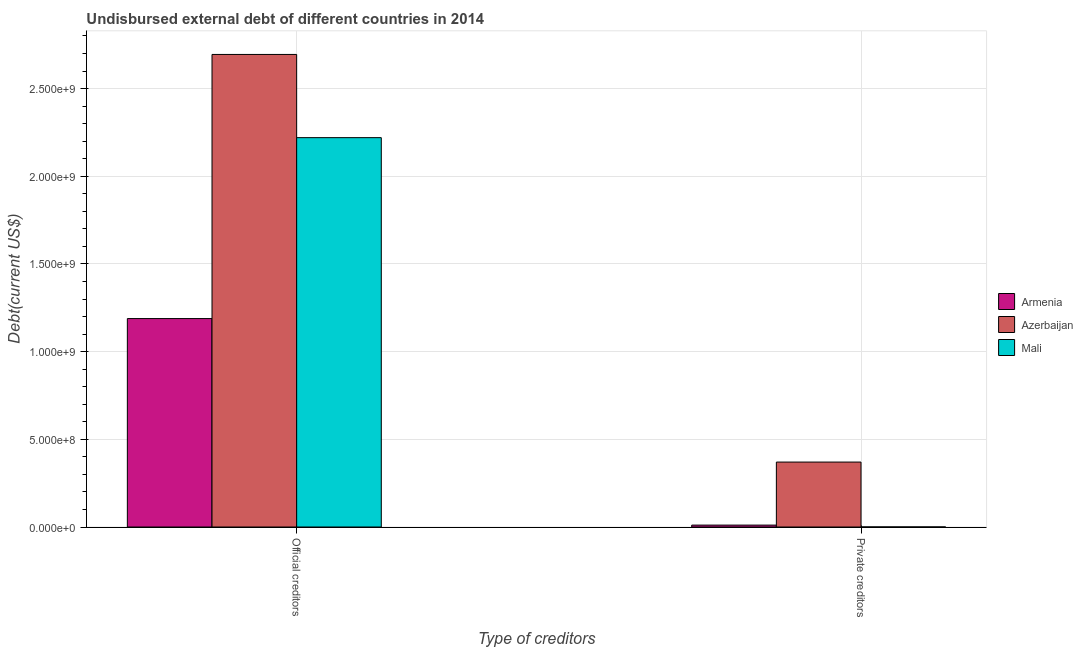Are the number of bars per tick equal to the number of legend labels?
Give a very brief answer. Yes. Are the number of bars on each tick of the X-axis equal?
Your answer should be compact. Yes. How many bars are there on the 2nd tick from the left?
Ensure brevity in your answer.  3. How many bars are there on the 2nd tick from the right?
Your answer should be very brief. 3. What is the label of the 2nd group of bars from the left?
Offer a terse response. Private creditors. What is the undisbursed external debt of private creditors in Armenia?
Give a very brief answer. 1.09e+07. Across all countries, what is the maximum undisbursed external debt of official creditors?
Make the answer very short. 2.69e+09. Across all countries, what is the minimum undisbursed external debt of official creditors?
Your response must be concise. 1.19e+09. In which country was the undisbursed external debt of official creditors maximum?
Make the answer very short. Azerbaijan. In which country was the undisbursed external debt of official creditors minimum?
Provide a short and direct response. Armenia. What is the total undisbursed external debt of private creditors in the graph?
Offer a very short reply. 3.82e+08. What is the difference between the undisbursed external debt of private creditors in Armenia and that in Mali?
Offer a very short reply. 1.05e+07. What is the difference between the undisbursed external debt of official creditors in Mali and the undisbursed external debt of private creditors in Armenia?
Keep it short and to the point. 2.21e+09. What is the average undisbursed external debt of official creditors per country?
Offer a very short reply. 2.03e+09. What is the difference between the undisbursed external debt of official creditors and undisbursed external debt of private creditors in Azerbaijan?
Your answer should be very brief. 2.32e+09. What is the ratio of the undisbursed external debt of official creditors in Mali to that in Armenia?
Your answer should be compact. 1.87. In how many countries, is the undisbursed external debt of private creditors greater than the average undisbursed external debt of private creditors taken over all countries?
Offer a terse response. 1. What does the 1st bar from the left in Private creditors represents?
Offer a terse response. Armenia. What does the 1st bar from the right in Official creditors represents?
Ensure brevity in your answer.  Mali. How many bars are there?
Your answer should be very brief. 6. Are all the bars in the graph horizontal?
Offer a terse response. No. Are the values on the major ticks of Y-axis written in scientific E-notation?
Provide a succinct answer. Yes. What is the title of the graph?
Your response must be concise. Undisbursed external debt of different countries in 2014. Does "United States" appear as one of the legend labels in the graph?
Keep it short and to the point. No. What is the label or title of the X-axis?
Keep it short and to the point. Type of creditors. What is the label or title of the Y-axis?
Provide a short and direct response. Debt(current US$). What is the Debt(current US$) of Armenia in Official creditors?
Provide a succinct answer. 1.19e+09. What is the Debt(current US$) in Azerbaijan in Official creditors?
Offer a terse response. 2.69e+09. What is the Debt(current US$) of Mali in Official creditors?
Your answer should be compact. 2.22e+09. What is the Debt(current US$) of Armenia in Private creditors?
Your answer should be compact. 1.09e+07. What is the Debt(current US$) of Azerbaijan in Private creditors?
Keep it short and to the point. 3.70e+08. What is the Debt(current US$) of Mali in Private creditors?
Provide a succinct answer. 3.87e+05. Across all Type of creditors, what is the maximum Debt(current US$) of Armenia?
Make the answer very short. 1.19e+09. Across all Type of creditors, what is the maximum Debt(current US$) of Azerbaijan?
Keep it short and to the point. 2.69e+09. Across all Type of creditors, what is the maximum Debt(current US$) in Mali?
Make the answer very short. 2.22e+09. Across all Type of creditors, what is the minimum Debt(current US$) in Armenia?
Keep it short and to the point. 1.09e+07. Across all Type of creditors, what is the minimum Debt(current US$) in Azerbaijan?
Your response must be concise. 3.70e+08. Across all Type of creditors, what is the minimum Debt(current US$) in Mali?
Give a very brief answer. 3.87e+05. What is the total Debt(current US$) in Armenia in the graph?
Your answer should be compact. 1.20e+09. What is the total Debt(current US$) of Azerbaijan in the graph?
Make the answer very short. 3.07e+09. What is the total Debt(current US$) of Mali in the graph?
Provide a succinct answer. 2.22e+09. What is the difference between the Debt(current US$) of Armenia in Official creditors and that in Private creditors?
Make the answer very short. 1.18e+09. What is the difference between the Debt(current US$) of Azerbaijan in Official creditors and that in Private creditors?
Make the answer very short. 2.32e+09. What is the difference between the Debt(current US$) of Mali in Official creditors and that in Private creditors?
Your response must be concise. 2.22e+09. What is the difference between the Debt(current US$) of Armenia in Official creditors and the Debt(current US$) of Azerbaijan in Private creditors?
Ensure brevity in your answer.  8.18e+08. What is the difference between the Debt(current US$) in Armenia in Official creditors and the Debt(current US$) in Mali in Private creditors?
Offer a very short reply. 1.19e+09. What is the difference between the Debt(current US$) in Azerbaijan in Official creditors and the Debt(current US$) in Mali in Private creditors?
Your answer should be compact. 2.69e+09. What is the average Debt(current US$) in Armenia per Type of creditors?
Your response must be concise. 6.00e+08. What is the average Debt(current US$) in Azerbaijan per Type of creditors?
Provide a short and direct response. 1.53e+09. What is the average Debt(current US$) in Mali per Type of creditors?
Give a very brief answer. 1.11e+09. What is the difference between the Debt(current US$) in Armenia and Debt(current US$) in Azerbaijan in Official creditors?
Give a very brief answer. -1.51e+09. What is the difference between the Debt(current US$) in Armenia and Debt(current US$) in Mali in Official creditors?
Offer a terse response. -1.03e+09. What is the difference between the Debt(current US$) of Azerbaijan and Debt(current US$) of Mali in Official creditors?
Your answer should be compact. 4.74e+08. What is the difference between the Debt(current US$) of Armenia and Debt(current US$) of Azerbaijan in Private creditors?
Your response must be concise. -3.59e+08. What is the difference between the Debt(current US$) in Armenia and Debt(current US$) in Mali in Private creditors?
Keep it short and to the point. 1.05e+07. What is the difference between the Debt(current US$) of Azerbaijan and Debt(current US$) of Mali in Private creditors?
Your answer should be very brief. 3.70e+08. What is the ratio of the Debt(current US$) of Armenia in Official creditors to that in Private creditors?
Offer a very short reply. 108.81. What is the ratio of the Debt(current US$) of Azerbaijan in Official creditors to that in Private creditors?
Provide a short and direct response. 7.28. What is the ratio of the Debt(current US$) of Mali in Official creditors to that in Private creditors?
Ensure brevity in your answer.  5737.4. What is the difference between the highest and the second highest Debt(current US$) of Armenia?
Make the answer very short. 1.18e+09. What is the difference between the highest and the second highest Debt(current US$) of Azerbaijan?
Provide a succinct answer. 2.32e+09. What is the difference between the highest and the second highest Debt(current US$) of Mali?
Ensure brevity in your answer.  2.22e+09. What is the difference between the highest and the lowest Debt(current US$) in Armenia?
Provide a short and direct response. 1.18e+09. What is the difference between the highest and the lowest Debt(current US$) in Azerbaijan?
Offer a very short reply. 2.32e+09. What is the difference between the highest and the lowest Debt(current US$) in Mali?
Keep it short and to the point. 2.22e+09. 